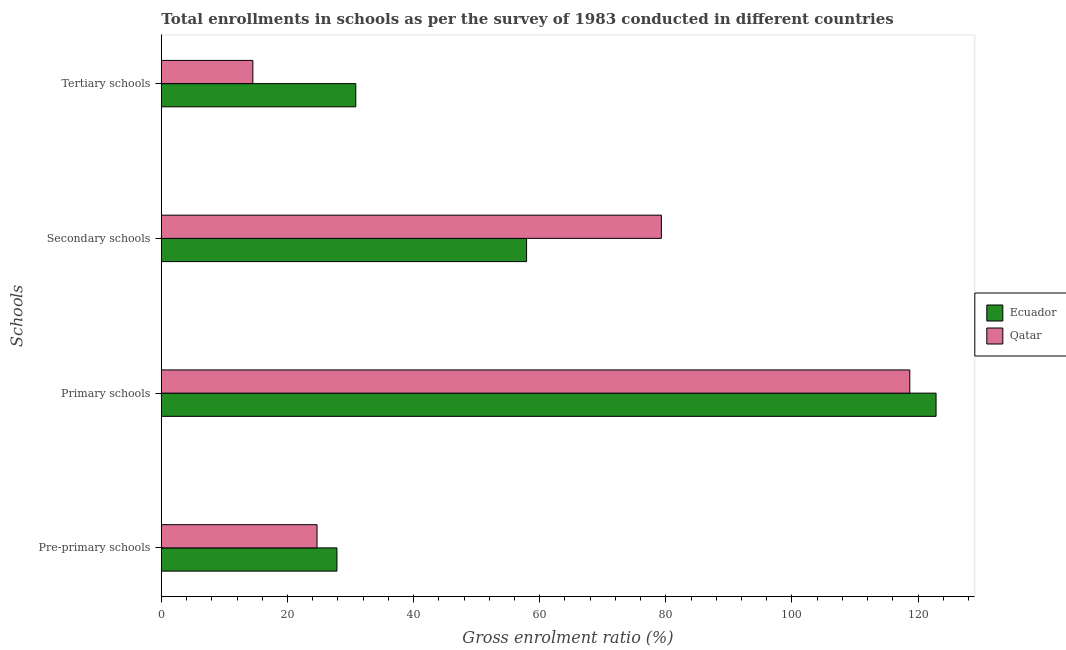How many different coloured bars are there?
Keep it short and to the point. 2. How many groups of bars are there?
Your answer should be very brief. 4. Are the number of bars on each tick of the Y-axis equal?
Keep it short and to the point. Yes. How many bars are there on the 3rd tick from the top?
Provide a succinct answer. 2. How many bars are there on the 2nd tick from the bottom?
Your answer should be very brief. 2. What is the label of the 3rd group of bars from the top?
Ensure brevity in your answer.  Primary schools. What is the gross enrolment ratio in pre-primary schools in Ecuador?
Keep it short and to the point. 27.85. Across all countries, what is the maximum gross enrolment ratio in primary schools?
Ensure brevity in your answer.  122.85. Across all countries, what is the minimum gross enrolment ratio in secondary schools?
Offer a very short reply. 57.92. In which country was the gross enrolment ratio in primary schools maximum?
Ensure brevity in your answer.  Ecuador. In which country was the gross enrolment ratio in pre-primary schools minimum?
Your response must be concise. Qatar. What is the total gross enrolment ratio in tertiary schools in the graph?
Offer a very short reply. 45.35. What is the difference between the gross enrolment ratio in secondary schools in Qatar and that in Ecuador?
Offer a terse response. 21.37. What is the difference between the gross enrolment ratio in primary schools in Qatar and the gross enrolment ratio in tertiary schools in Ecuador?
Ensure brevity in your answer.  87.85. What is the average gross enrolment ratio in primary schools per country?
Ensure brevity in your answer.  120.77. What is the difference between the gross enrolment ratio in pre-primary schools and gross enrolment ratio in primary schools in Qatar?
Ensure brevity in your answer.  -93.99. What is the ratio of the gross enrolment ratio in secondary schools in Qatar to that in Ecuador?
Provide a succinct answer. 1.37. Is the gross enrolment ratio in secondary schools in Ecuador less than that in Qatar?
Your response must be concise. Yes. Is the difference between the gross enrolment ratio in primary schools in Ecuador and Qatar greater than the difference between the gross enrolment ratio in pre-primary schools in Ecuador and Qatar?
Your response must be concise. Yes. What is the difference between the highest and the second highest gross enrolment ratio in tertiary schools?
Your answer should be compact. 16.32. What is the difference between the highest and the lowest gross enrolment ratio in pre-primary schools?
Offer a terse response. 3.16. What does the 1st bar from the top in Secondary schools represents?
Keep it short and to the point. Qatar. What does the 2nd bar from the bottom in Tertiary schools represents?
Give a very brief answer. Qatar. Is it the case that in every country, the sum of the gross enrolment ratio in pre-primary schools and gross enrolment ratio in primary schools is greater than the gross enrolment ratio in secondary schools?
Make the answer very short. Yes. How many bars are there?
Keep it short and to the point. 8. What is the difference between two consecutive major ticks on the X-axis?
Your response must be concise. 20. Does the graph contain any zero values?
Keep it short and to the point. No. Does the graph contain grids?
Keep it short and to the point. No. Where does the legend appear in the graph?
Your response must be concise. Center right. What is the title of the graph?
Your response must be concise. Total enrollments in schools as per the survey of 1983 conducted in different countries. Does "India" appear as one of the legend labels in the graph?
Your response must be concise. No. What is the label or title of the Y-axis?
Provide a short and direct response. Schools. What is the Gross enrolment ratio (%) in Ecuador in Pre-primary schools?
Offer a terse response. 27.85. What is the Gross enrolment ratio (%) of Qatar in Pre-primary schools?
Your answer should be compact. 24.69. What is the Gross enrolment ratio (%) in Ecuador in Primary schools?
Provide a short and direct response. 122.85. What is the Gross enrolment ratio (%) of Qatar in Primary schools?
Your answer should be very brief. 118.68. What is the Gross enrolment ratio (%) in Ecuador in Secondary schools?
Offer a terse response. 57.92. What is the Gross enrolment ratio (%) of Qatar in Secondary schools?
Provide a short and direct response. 79.29. What is the Gross enrolment ratio (%) in Ecuador in Tertiary schools?
Keep it short and to the point. 30.83. What is the Gross enrolment ratio (%) in Qatar in Tertiary schools?
Give a very brief answer. 14.52. Across all Schools, what is the maximum Gross enrolment ratio (%) of Ecuador?
Provide a short and direct response. 122.85. Across all Schools, what is the maximum Gross enrolment ratio (%) of Qatar?
Provide a short and direct response. 118.68. Across all Schools, what is the minimum Gross enrolment ratio (%) in Ecuador?
Ensure brevity in your answer.  27.85. Across all Schools, what is the minimum Gross enrolment ratio (%) in Qatar?
Your response must be concise. 14.52. What is the total Gross enrolment ratio (%) in Ecuador in the graph?
Provide a short and direct response. 239.45. What is the total Gross enrolment ratio (%) of Qatar in the graph?
Offer a very short reply. 237.18. What is the difference between the Gross enrolment ratio (%) in Ecuador in Pre-primary schools and that in Primary schools?
Ensure brevity in your answer.  -95. What is the difference between the Gross enrolment ratio (%) in Qatar in Pre-primary schools and that in Primary schools?
Offer a very short reply. -93.99. What is the difference between the Gross enrolment ratio (%) of Ecuador in Pre-primary schools and that in Secondary schools?
Your response must be concise. -30.07. What is the difference between the Gross enrolment ratio (%) in Qatar in Pre-primary schools and that in Secondary schools?
Make the answer very short. -54.6. What is the difference between the Gross enrolment ratio (%) in Ecuador in Pre-primary schools and that in Tertiary schools?
Your response must be concise. -2.99. What is the difference between the Gross enrolment ratio (%) in Qatar in Pre-primary schools and that in Tertiary schools?
Offer a terse response. 10.18. What is the difference between the Gross enrolment ratio (%) in Ecuador in Primary schools and that in Secondary schools?
Your answer should be compact. 64.93. What is the difference between the Gross enrolment ratio (%) in Qatar in Primary schools and that in Secondary schools?
Offer a very short reply. 39.39. What is the difference between the Gross enrolment ratio (%) in Ecuador in Primary schools and that in Tertiary schools?
Provide a short and direct response. 92.01. What is the difference between the Gross enrolment ratio (%) in Qatar in Primary schools and that in Tertiary schools?
Keep it short and to the point. 104.17. What is the difference between the Gross enrolment ratio (%) of Ecuador in Secondary schools and that in Tertiary schools?
Provide a succinct answer. 27.08. What is the difference between the Gross enrolment ratio (%) of Qatar in Secondary schools and that in Tertiary schools?
Make the answer very short. 64.77. What is the difference between the Gross enrolment ratio (%) of Ecuador in Pre-primary schools and the Gross enrolment ratio (%) of Qatar in Primary schools?
Offer a terse response. -90.84. What is the difference between the Gross enrolment ratio (%) of Ecuador in Pre-primary schools and the Gross enrolment ratio (%) of Qatar in Secondary schools?
Keep it short and to the point. -51.44. What is the difference between the Gross enrolment ratio (%) in Ecuador in Pre-primary schools and the Gross enrolment ratio (%) in Qatar in Tertiary schools?
Keep it short and to the point. 13.33. What is the difference between the Gross enrolment ratio (%) in Ecuador in Primary schools and the Gross enrolment ratio (%) in Qatar in Secondary schools?
Provide a succinct answer. 43.56. What is the difference between the Gross enrolment ratio (%) in Ecuador in Primary schools and the Gross enrolment ratio (%) in Qatar in Tertiary schools?
Provide a short and direct response. 108.33. What is the difference between the Gross enrolment ratio (%) of Ecuador in Secondary schools and the Gross enrolment ratio (%) of Qatar in Tertiary schools?
Your response must be concise. 43.4. What is the average Gross enrolment ratio (%) of Ecuador per Schools?
Provide a succinct answer. 59.86. What is the average Gross enrolment ratio (%) in Qatar per Schools?
Give a very brief answer. 59.3. What is the difference between the Gross enrolment ratio (%) in Ecuador and Gross enrolment ratio (%) in Qatar in Pre-primary schools?
Provide a short and direct response. 3.16. What is the difference between the Gross enrolment ratio (%) of Ecuador and Gross enrolment ratio (%) of Qatar in Primary schools?
Your answer should be compact. 4.16. What is the difference between the Gross enrolment ratio (%) of Ecuador and Gross enrolment ratio (%) of Qatar in Secondary schools?
Your answer should be very brief. -21.37. What is the difference between the Gross enrolment ratio (%) in Ecuador and Gross enrolment ratio (%) in Qatar in Tertiary schools?
Your answer should be very brief. 16.32. What is the ratio of the Gross enrolment ratio (%) in Ecuador in Pre-primary schools to that in Primary schools?
Provide a short and direct response. 0.23. What is the ratio of the Gross enrolment ratio (%) of Qatar in Pre-primary schools to that in Primary schools?
Ensure brevity in your answer.  0.21. What is the ratio of the Gross enrolment ratio (%) in Ecuador in Pre-primary schools to that in Secondary schools?
Ensure brevity in your answer.  0.48. What is the ratio of the Gross enrolment ratio (%) of Qatar in Pre-primary schools to that in Secondary schools?
Your response must be concise. 0.31. What is the ratio of the Gross enrolment ratio (%) in Ecuador in Pre-primary schools to that in Tertiary schools?
Provide a succinct answer. 0.9. What is the ratio of the Gross enrolment ratio (%) of Qatar in Pre-primary schools to that in Tertiary schools?
Provide a short and direct response. 1.7. What is the ratio of the Gross enrolment ratio (%) of Ecuador in Primary schools to that in Secondary schools?
Provide a short and direct response. 2.12. What is the ratio of the Gross enrolment ratio (%) in Qatar in Primary schools to that in Secondary schools?
Keep it short and to the point. 1.5. What is the ratio of the Gross enrolment ratio (%) in Ecuador in Primary schools to that in Tertiary schools?
Offer a very short reply. 3.98. What is the ratio of the Gross enrolment ratio (%) of Qatar in Primary schools to that in Tertiary schools?
Offer a very short reply. 8.18. What is the ratio of the Gross enrolment ratio (%) of Ecuador in Secondary schools to that in Tertiary schools?
Give a very brief answer. 1.88. What is the ratio of the Gross enrolment ratio (%) in Qatar in Secondary schools to that in Tertiary schools?
Offer a terse response. 5.46. What is the difference between the highest and the second highest Gross enrolment ratio (%) in Ecuador?
Offer a very short reply. 64.93. What is the difference between the highest and the second highest Gross enrolment ratio (%) in Qatar?
Provide a short and direct response. 39.39. What is the difference between the highest and the lowest Gross enrolment ratio (%) of Ecuador?
Keep it short and to the point. 95. What is the difference between the highest and the lowest Gross enrolment ratio (%) of Qatar?
Your answer should be compact. 104.17. 